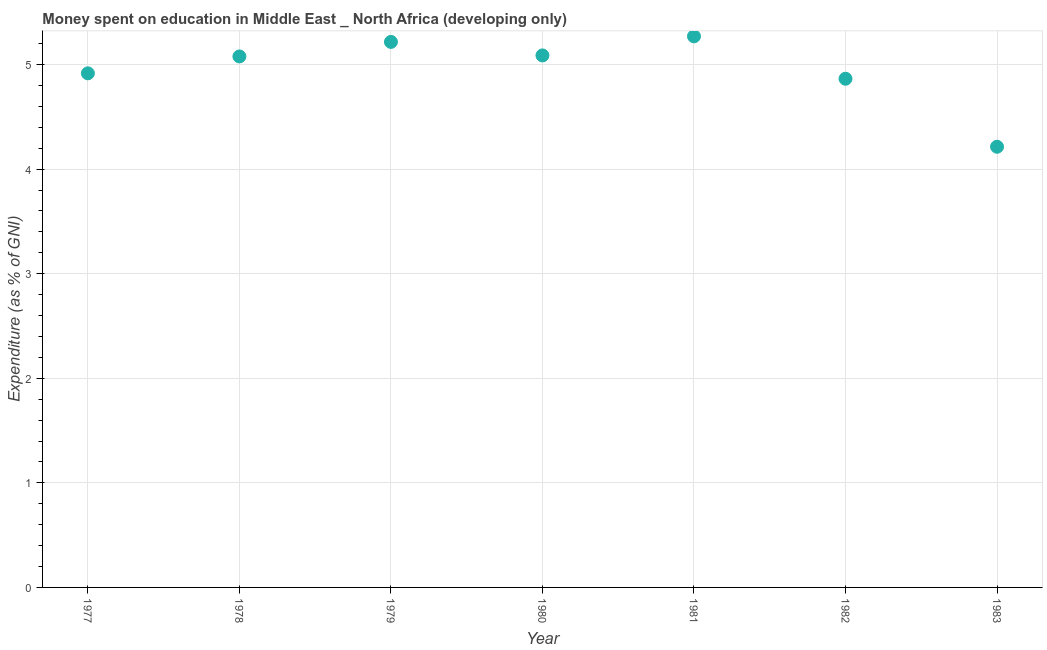What is the expenditure on education in 1978?
Provide a succinct answer. 5.08. Across all years, what is the maximum expenditure on education?
Provide a succinct answer. 5.27. Across all years, what is the minimum expenditure on education?
Make the answer very short. 4.21. In which year was the expenditure on education minimum?
Ensure brevity in your answer.  1983. What is the sum of the expenditure on education?
Your answer should be very brief. 34.64. What is the difference between the expenditure on education in 1977 and 1978?
Give a very brief answer. -0.16. What is the average expenditure on education per year?
Your answer should be compact. 4.95. What is the median expenditure on education?
Keep it short and to the point. 5.08. What is the ratio of the expenditure on education in 1980 to that in 1981?
Provide a succinct answer. 0.97. Is the difference between the expenditure on education in 1980 and 1983 greater than the difference between any two years?
Make the answer very short. No. What is the difference between the highest and the second highest expenditure on education?
Keep it short and to the point. 0.05. What is the difference between the highest and the lowest expenditure on education?
Your answer should be compact. 1.06. In how many years, is the expenditure on education greater than the average expenditure on education taken over all years?
Offer a very short reply. 4. How many years are there in the graph?
Offer a terse response. 7. Does the graph contain any zero values?
Provide a succinct answer. No. What is the title of the graph?
Your answer should be compact. Money spent on education in Middle East _ North Africa (developing only). What is the label or title of the Y-axis?
Give a very brief answer. Expenditure (as % of GNI). What is the Expenditure (as % of GNI) in 1977?
Your answer should be compact. 4.92. What is the Expenditure (as % of GNI) in 1978?
Keep it short and to the point. 5.08. What is the Expenditure (as % of GNI) in 1979?
Your response must be concise. 5.22. What is the Expenditure (as % of GNI) in 1980?
Your answer should be very brief. 5.09. What is the Expenditure (as % of GNI) in 1981?
Make the answer very short. 5.27. What is the Expenditure (as % of GNI) in 1982?
Give a very brief answer. 4.86. What is the Expenditure (as % of GNI) in 1983?
Give a very brief answer. 4.21. What is the difference between the Expenditure (as % of GNI) in 1977 and 1978?
Your response must be concise. -0.16. What is the difference between the Expenditure (as % of GNI) in 1977 and 1979?
Your response must be concise. -0.3. What is the difference between the Expenditure (as % of GNI) in 1977 and 1980?
Offer a very short reply. -0.17. What is the difference between the Expenditure (as % of GNI) in 1977 and 1981?
Provide a succinct answer. -0.35. What is the difference between the Expenditure (as % of GNI) in 1977 and 1982?
Provide a succinct answer. 0.05. What is the difference between the Expenditure (as % of GNI) in 1977 and 1983?
Keep it short and to the point. 0.7. What is the difference between the Expenditure (as % of GNI) in 1978 and 1979?
Give a very brief answer. -0.14. What is the difference between the Expenditure (as % of GNI) in 1978 and 1980?
Provide a short and direct response. -0.01. What is the difference between the Expenditure (as % of GNI) in 1978 and 1981?
Offer a very short reply. -0.19. What is the difference between the Expenditure (as % of GNI) in 1978 and 1982?
Your response must be concise. 0.21. What is the difference between the Expenditure (as % of GNI) in 1978 and 1983?
Offer a terse response. 0.86. What is the difference between the Expenditure (as % of GNI) in 1979 and 1980?
Keep it short and to the point. 0.13. What is the difference between the Expenditure (as % of GNI) in 1979 and 1981?
Give a very brief answer. -0.05. What is the difference between the Expenditure (as % of GNI) in 1979 and 1982?
Ensure brevity in your answer.  0.35. What is the difference between the Expenditure (as % of GNI) in 1979 and 1983?
Provide a succinct answer. 1. What is the difference between the Expenditure (as % of GNI) in 1980 and 1981?
Your answer should be compact. -0.18. What is the difference between the Expenditure (as % of GNI) in 1980 and 1982?
Your answer should be compact. 0.22. What is the difference between the Expenditure (as % of GNI) in 1980 and 1983?
Ensure brevity in your answer.  0.87. What is the difference between the Expenditure (as % of GNI) in 1981 and 1982?
Give a very brief answer. 0.41. What is the difference between the Expenditure (as % of GNI) in 1981 and 1983?
Make the answer very short. 1.06. What is the difference between the Expenditure (as % of GNI) in 1982 and 1983?
Ensure brevity in your answer.  0.65. What is the ratio of the Expenditure (as % of GNI) in 1977 to that in 1978?
Your answer should be compact. 0.97. What is the ratio of the Expenditure (as % of GNI) in 1977 to that in 1979?
Offer a terse response. 0.94. What is the ratio of the Expenditure (as % of GNI) in 1977 to that in 1980?
Your answer should be very brief. 0.97. What is the ratio of the Expenditure (as % of GNI) in 1977 to that in 1981?
Give a very brief answer. 0.93. What is the ratio of the Expenditure (as % of GNI) in 1977 to that in 1983?
Your answer should be compact. 1.17. What is the ratio of the Expenditure (as % of GNI) in 1978 to that in 1980?
Offer a very short reply. 1. What is the ratio of the Expenditure (as % of GNI) in 1978 to that in 1981?
Give a very brief answer. 0.96. What is the ratio of the Expenditure (as % of GNI) in 1978 to that in 1982?
Your answer should be very brief. 1.04. What is the ratio of the Expenditure (as % of GNI) in 1978 to that in 1983?
Your answer should be compact. 1.21. What is the ratio of the Expenditure (as % of GNI) in 1979 to that in 1981?
Make the answer very short. 0.99. What is the ratio of the Expenditure (as % of GNI) in 1979 to that in 1982?
Your answer should be very brief. 1.07. What is the ratio of the Expenditure (as % of GNI) in 1979 to that in 1983?
Your answer should be very brief. 1.24. What is the ratio of the Expenditure (as % of GNI) in 1980 to that in 1981?
Give a very brief answer. 0.96. What is the ratio of the Expenditure (as % of GNI) in 1980 to that in 1982?
Ensure brevity in your answer.  1.05. What is the ratio of the Expenditure (as % of GNI) in 1980 to that in 1983?
Give a very brief answer. 1.21. What is the ratio of the Expenditure (as % of GNI) in 1981 to that in 1982?
Your answer should be compact. 1.08. What is the ratio of the Expenditure (as % of GNI) in 1981 to that in 1983?
Offer a terse response. 1.25. What is the ratio of the Expenditure (as % of GNI) in 1982 to that in 1983?
Provide a succinct answer. 1.15. 